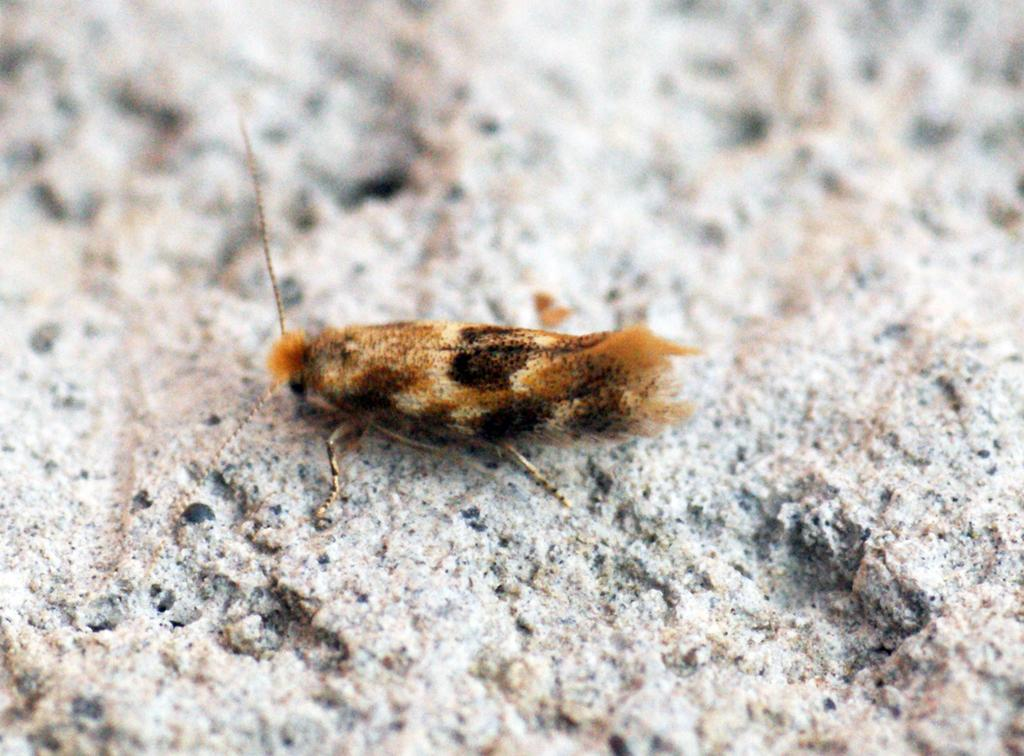What type of insect is present in the image? There is a moth in the image. Where is the moth located? The moth is on a rock. What type of song is the moth singing in the image? There is no indication that the moth is singing in the image, as insects do not have the ability to sing songs. 